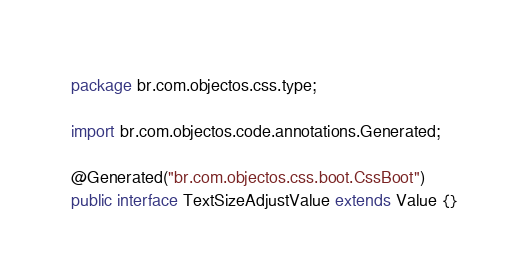Convert code to text. <code><loc_0><loc_0><loc_500><loc_500><_Java_>package br.com.objectos.css.type;

import br.com.objectos.code.annotations.Generated;

@Generated("br.com.objectos.css.boot.CssBoot")
public interface TextSizeAdjustValue extends Value {}</code> 